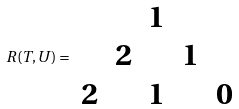<formula> <loc_0><loc_0><loc_500><loc_500>R ( T , U ) = \begin{array} { c c c c c } & & 1 & & \\ & 2 & & 1 & \\ 2 & & 1 & & 0 \end{array}</formula> 